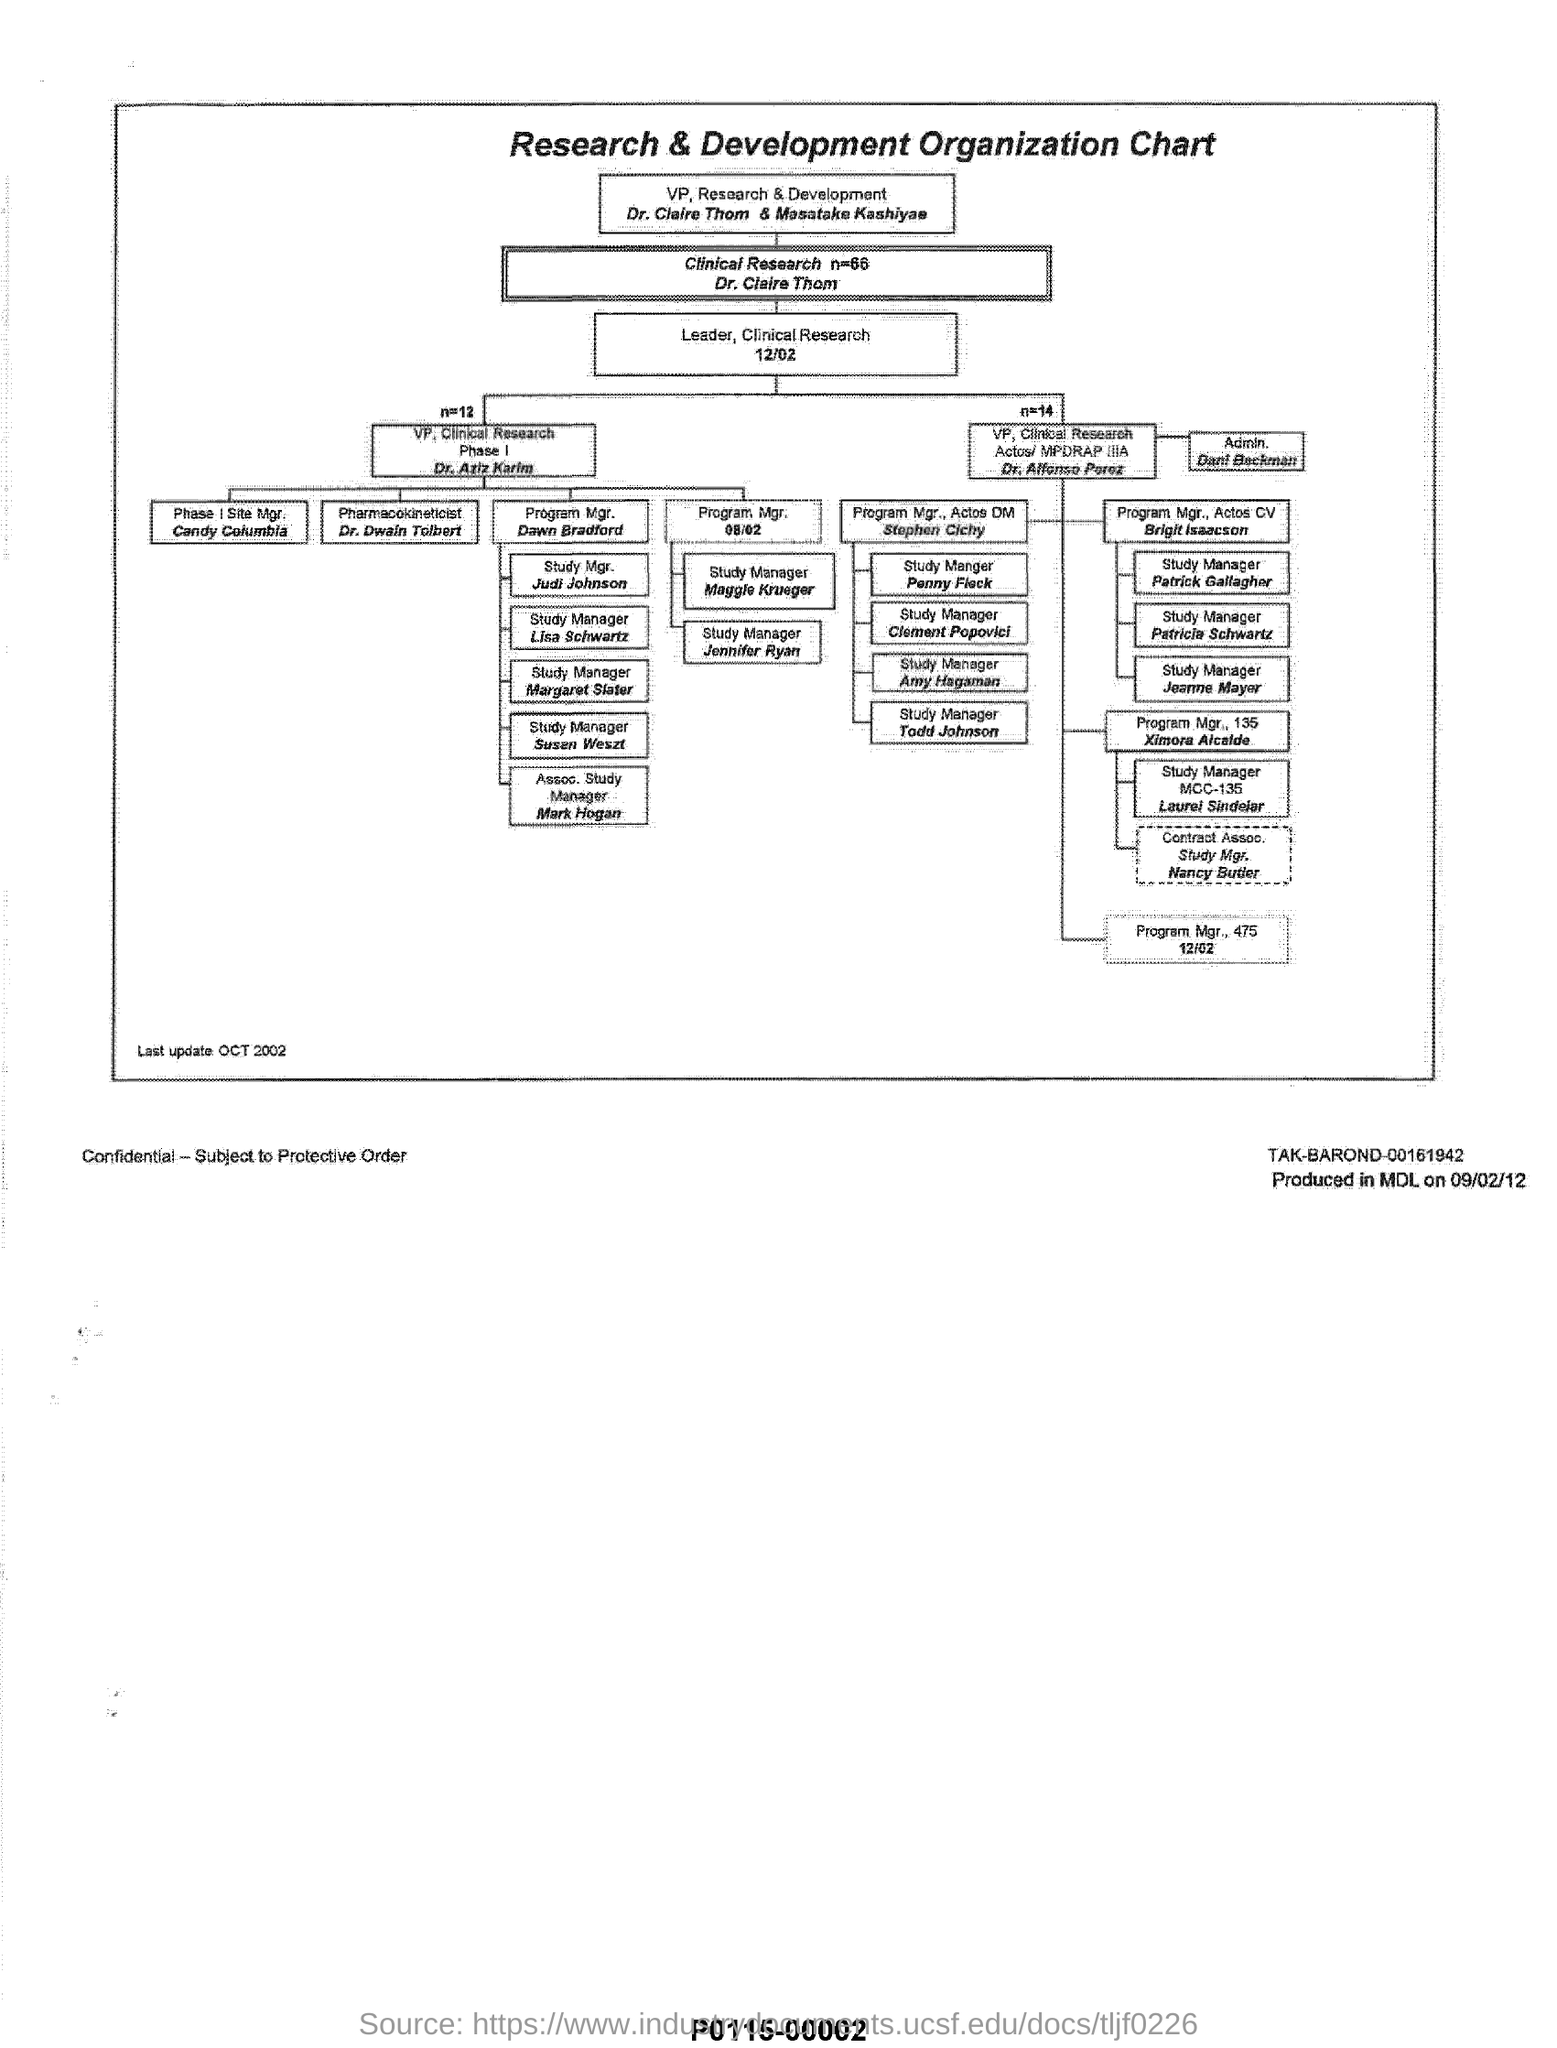What is the title of the chart ?
Your answer should be compact. Research & Development Organization Chart. Who is the VP of Research & Development?
Ensure brevity in your answer.  Dr. Claire Thom & Masatake Kashiyae. What is the job title of Dr. Dwain Tolbert?
Your answer should be very brief. Pharmacokineticist. When is the document last updated?
Provide a succinct answer. OCT 2002. 